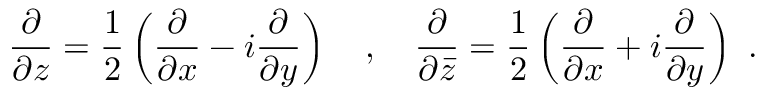Convert formula to latex. <formula><loc_0><loc_0><loc_500><loc_500>{ \frac { \partial } { \partial z } } = { \frac { 1 } { 2 } } \left ( { \frac { \partial } { \partial x } } - i { \frac { \partial } { \partial y } } \right ) \quad , \quad \frac { \partial } { \partial { \bar { z } } } = { \frac { 1 } { 2 } } \left ( { \frac { \partial } { \partial x } } + i { \frac { \partial } { \partial y } } \right ) \ .</formula> 